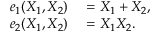Convert formula to latex. <formula><loc_0><loc_0><loc_500><loc_500>\begin{array} { r l } { e _ { 1 } ( X _ { 1 } , X _ { 2 } ) } & = X _ { 1 } + X _ { 2 } , } \\ { e _ { 2 } ( X _ { 1 } , X _ { 2 } ) } & = X _ { 1 } X _ { 2 } . \, } \end{array}</formula> 